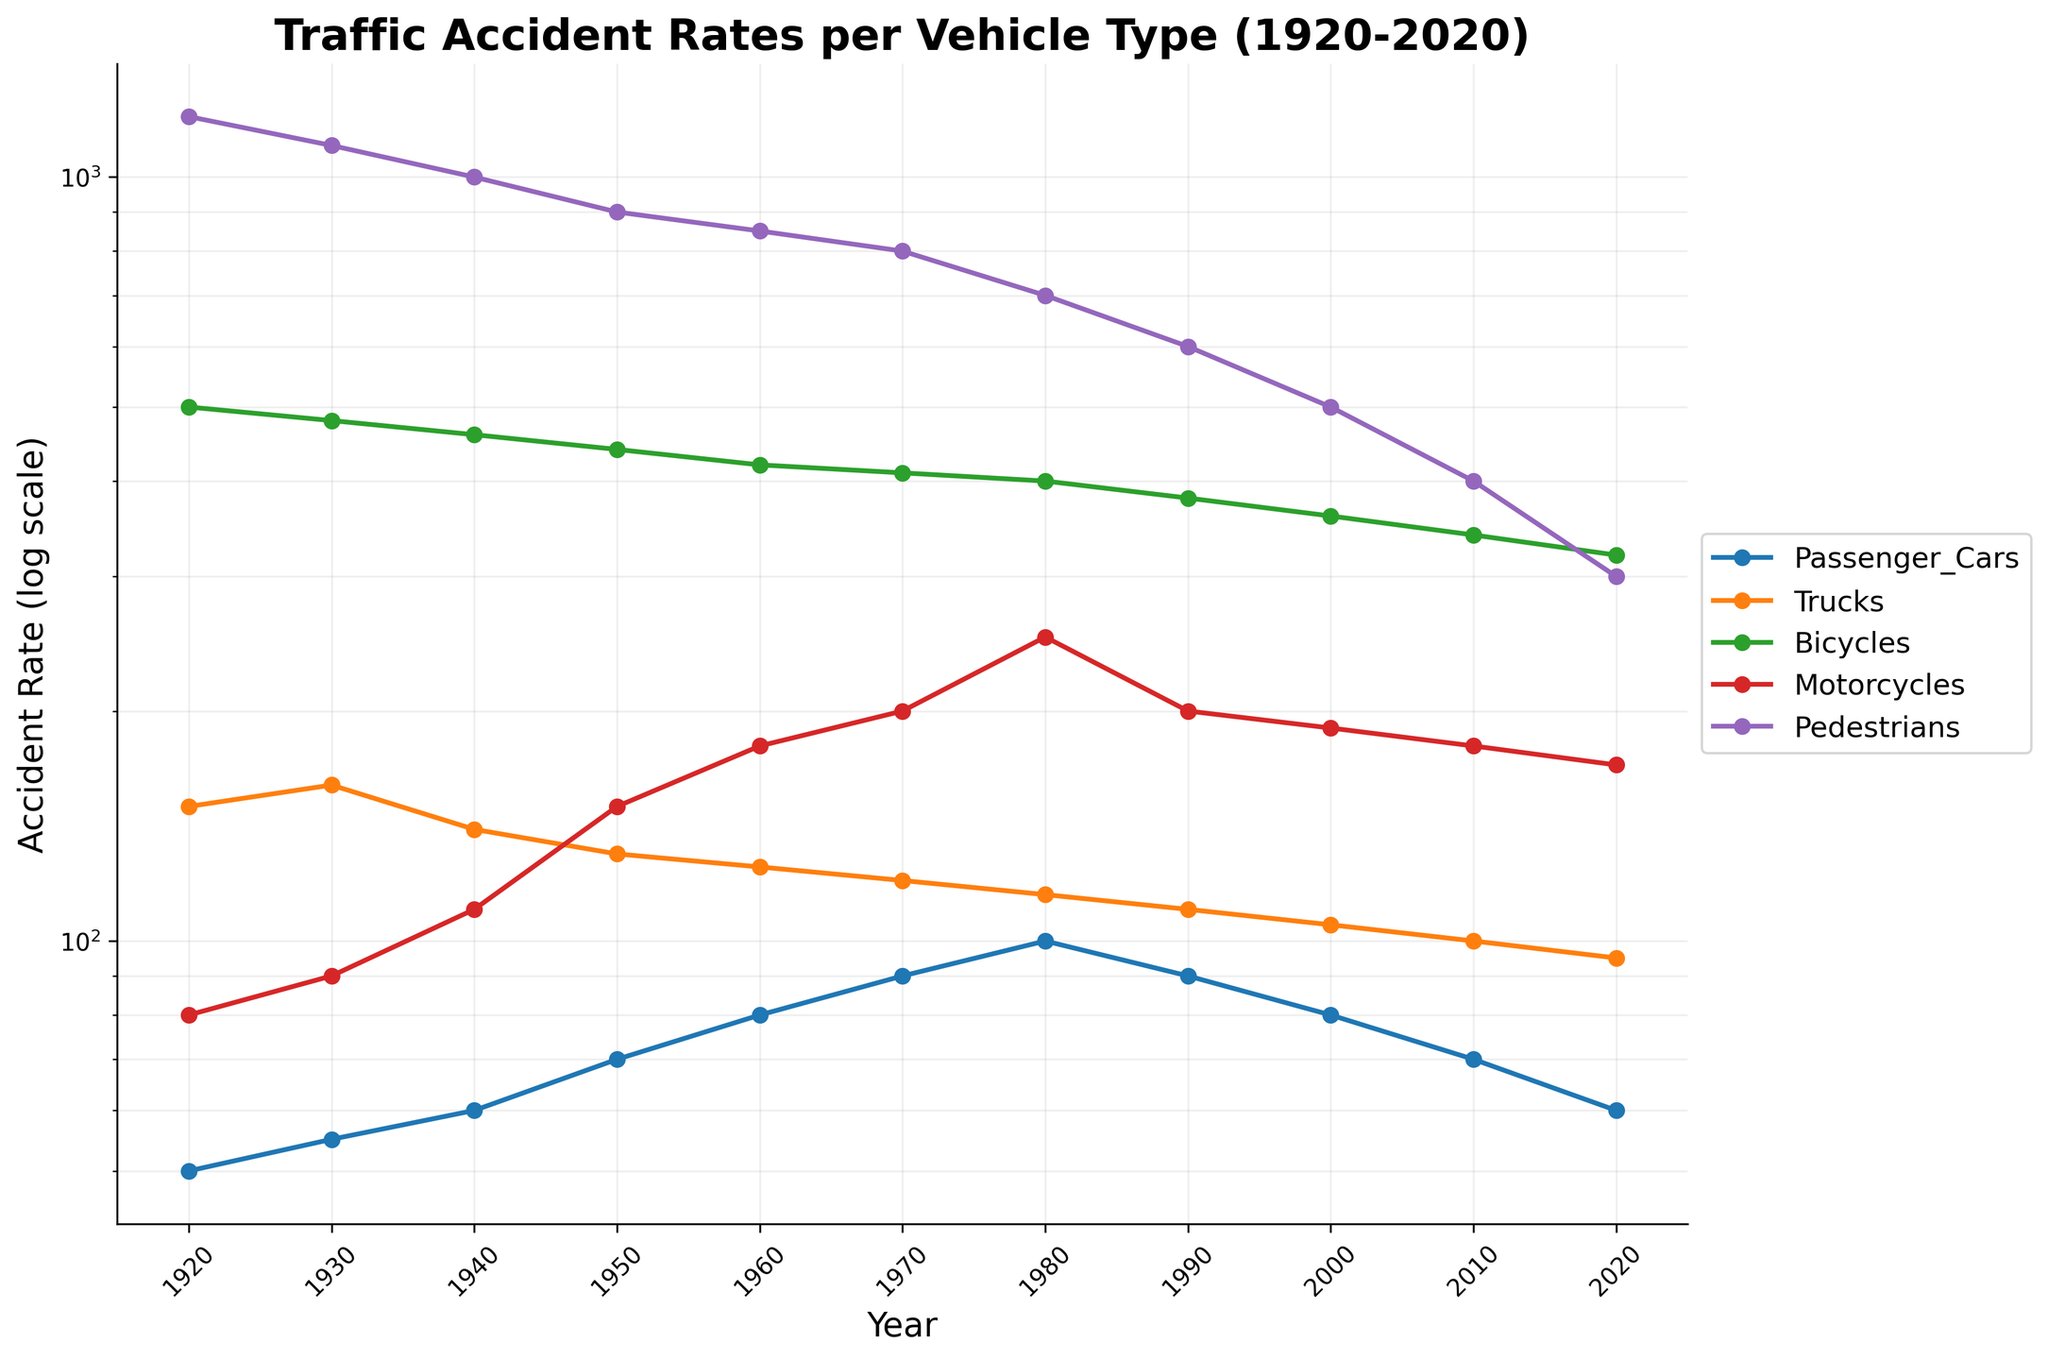What's the title of the figure? The title is displayed prominently at the top of the figure. It reads "Traffic Accident Rates per Vehicle Type (1920-2020)"
Answer: Traffic Accident Rates per Vehicle Type (1920-2020) What is the y-axis scale? The y-axis scale is indicated by the repeated "log" on the axis and the logarithmically spaced values. It is a log scale.
Answer: Log scale Which vehicle type had the highest accident rate in 1920? Look at the 1920s data points for each vehicle type. The highest point is for Pedestrians at a rate of 1200.
Answer: Pedestrians What is the accident rate for Motorcycles in 1980? Find the point corresponding to Motorcycles in 1980. It intersects at 250.
Answer: 250 Which vehicle type shows the most significant decrease in accident rates from 1920 to 2020? Compare the differences in accident rates from 1920 to 2020 for all vehicle types. Pedestrians drop from 1200 to 300, the largest decrease.
Answer: Pedestrians How does the accident rate for Trucks compare between 1950 and 2020? Look at the data points for Trucks in 1950 and 2020. In 1950, it's at 130, and in 2020, at 95. The rate decreases.
Answer: Decreases What general trend is observed for the accident rates of Passenger Cars over the century? Follow the line for Passenger Cars from 1920 to 2020. The trend shows a decrease from 50 to 60, with a short-term increase around 1980.
Answer: Decreasing What was the accident rate of Bicycles in 1960, and how does it compare to 2010? Check the accident rates for Bicycles in 1960 (420) and 2010 (340). The rate decreases by 80.
Answer: Decreases by 80 Which vehicle type had the closest rates in 1970 and 1990? Compare accident rates for all vehicle types in 1970 and 1990. Trucks had rates of 120 in 1970 and 110 in 1990, which are the closest.
Answer: Trucks Around which decade did Motorcycles experience the most rapid increase in accident rates? Follow the line for Motorcycles and find where the steepest increase occurs. Between 1940 and 1980, the rate increased from 110 to 250. The most rapid increase is seen between 1960 and 1970, from 180 to 200.
Answer: 1960-1970 